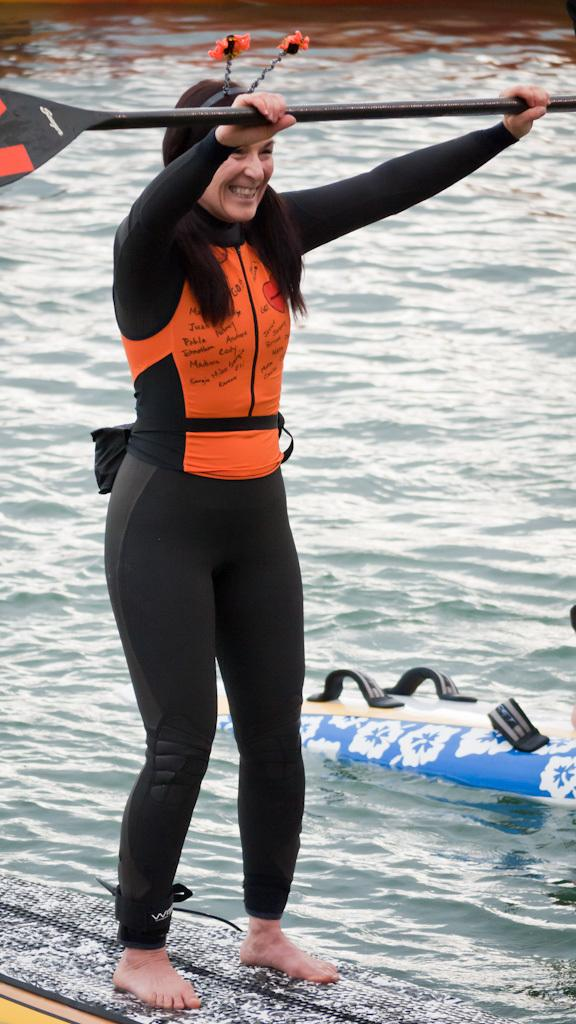Who is present in the image? There is a woman in the image. What is the woman holding in her hands? The woman is holding a pedal in her hands. What is the woman standing on in the image? The woman is standing on a surfboard. What can be seen in the background of the image? There is water visible in the image. Are there any other surfboards in the image? Yes, there is another surfboard on the right side of the image. How many spiders are crawling on the woman's statement in the image? There are no spiders or statements present in the image. 